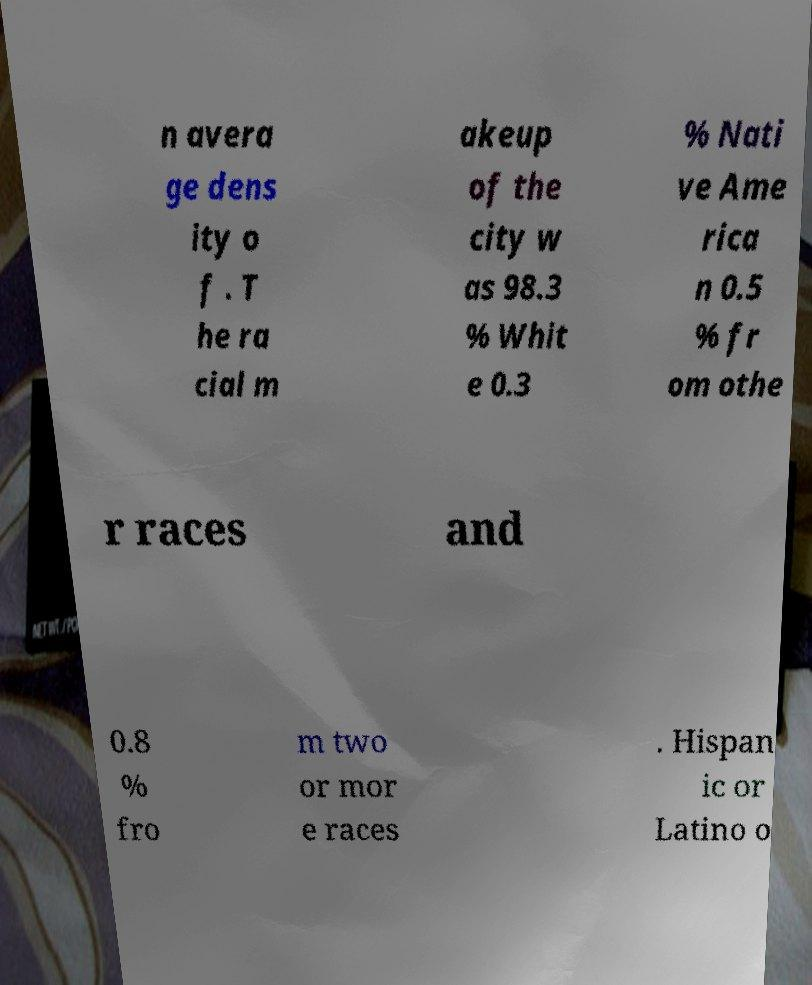Could you assist in decoding the text presented in this image and type it out clearly? n avera ge dens ity o f . T he ra cial m akeup of the city w as 98.3 % Whit e 0.3 % Nati ve Ame rica n 0.5 % fr om othe r races and 0.8 % fro m two or mor e races . Hispan ic or Latino o 